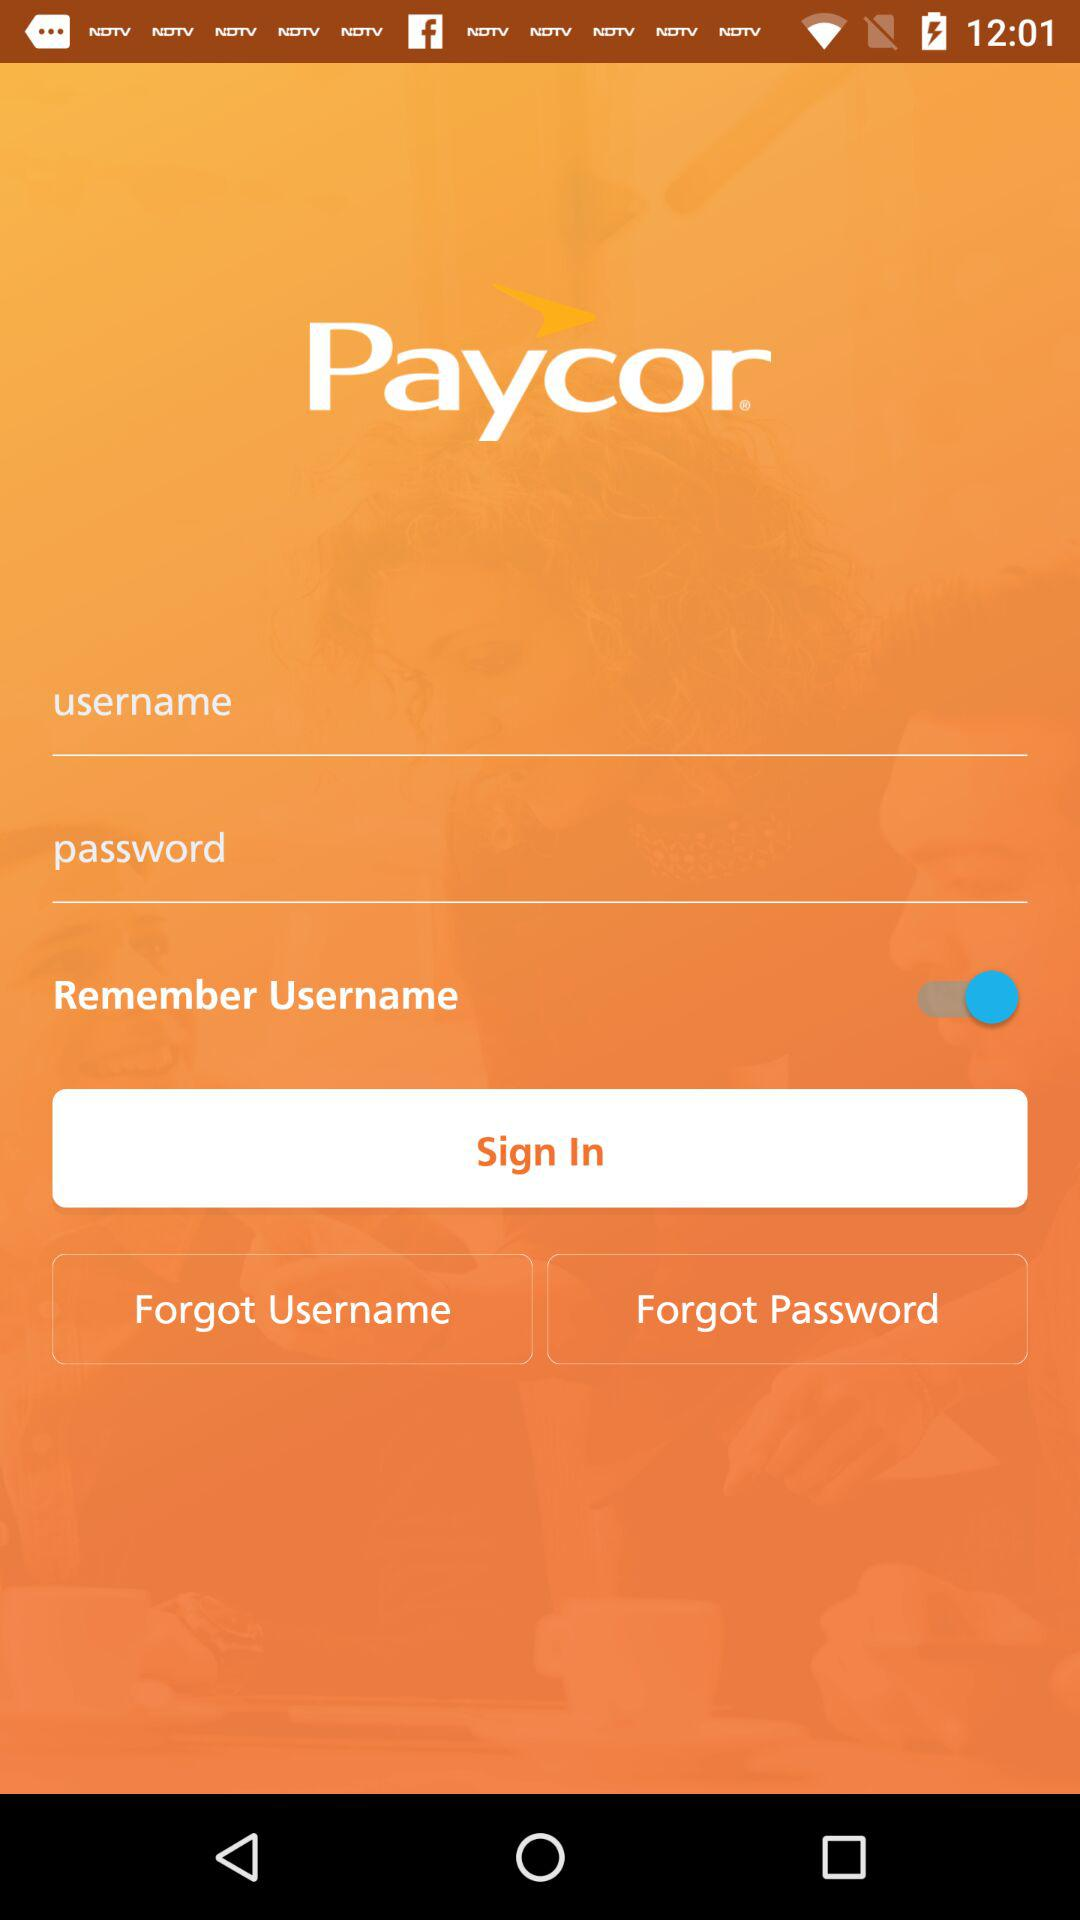What is the status of "Remember Username"? The status is "on". 